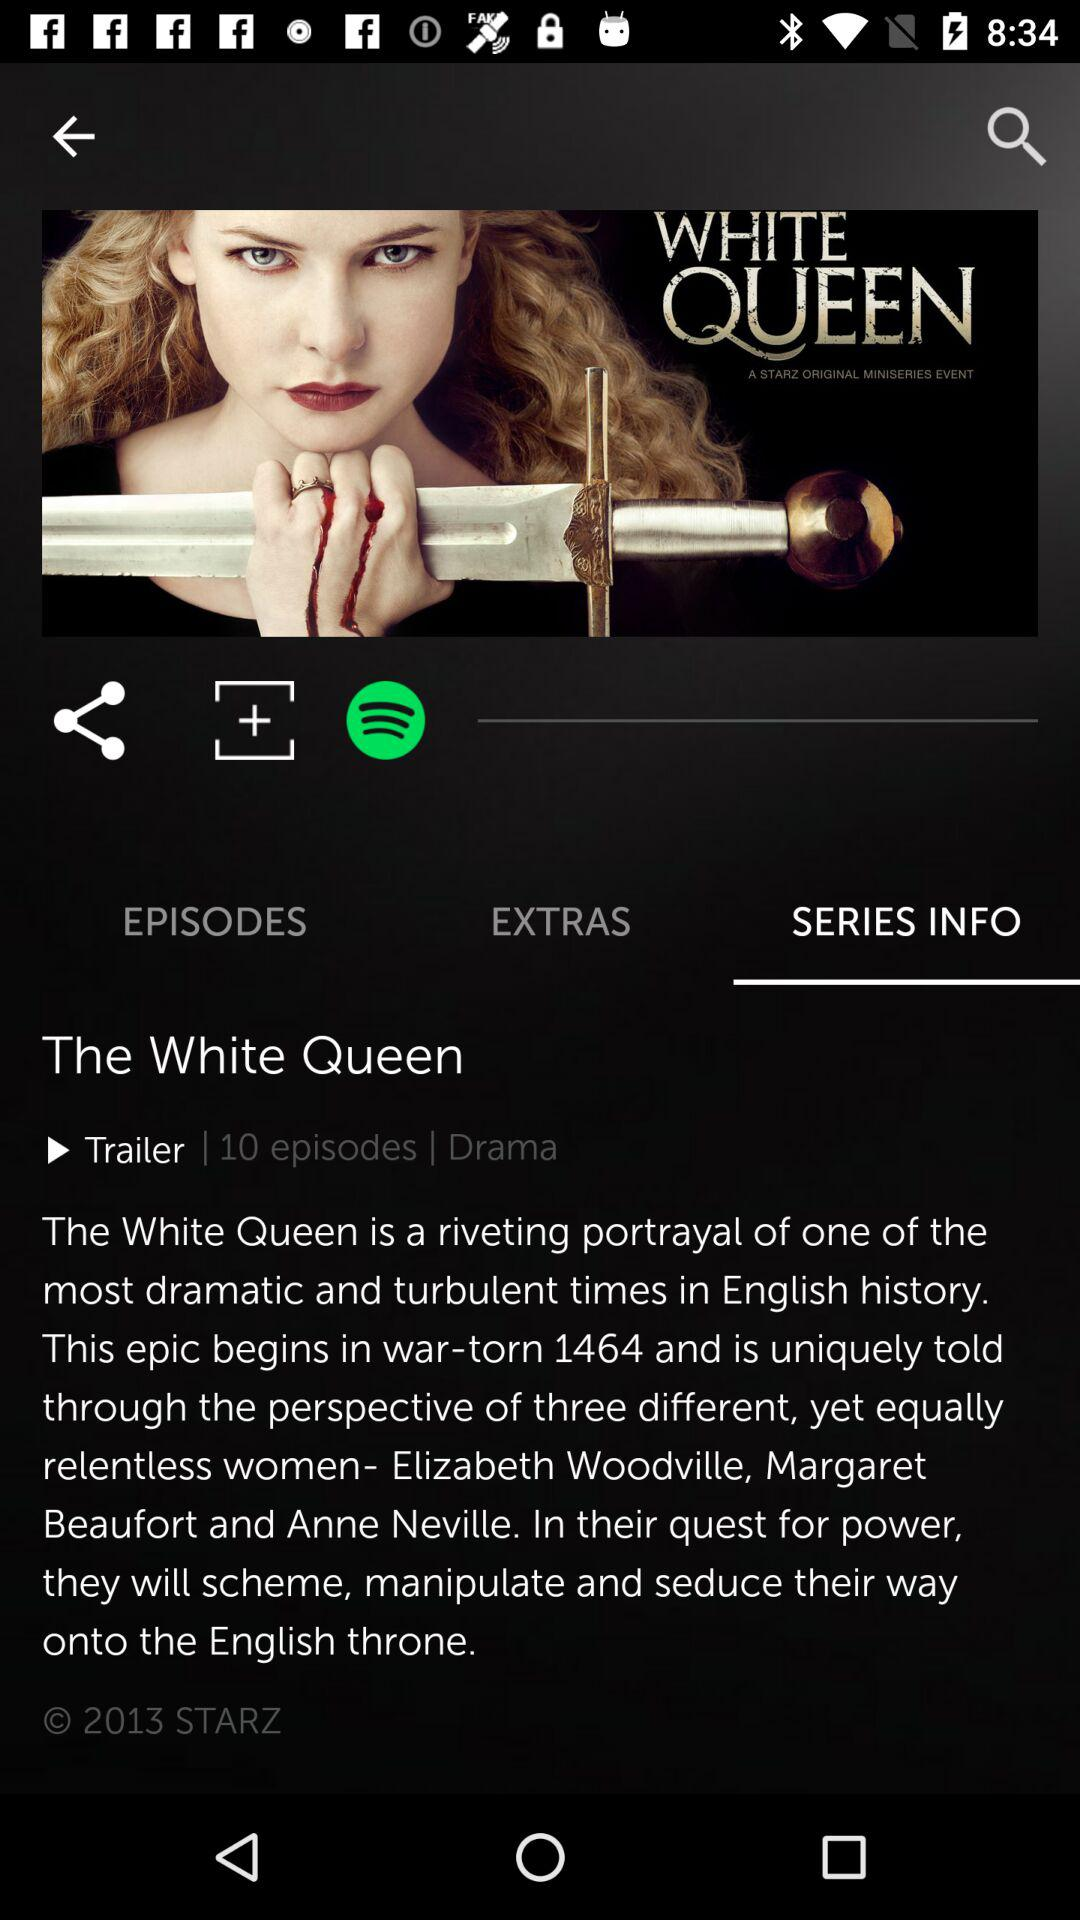How long is the trailer?
When the provided information is insufficient, respond with <no answer>. <no answer> 